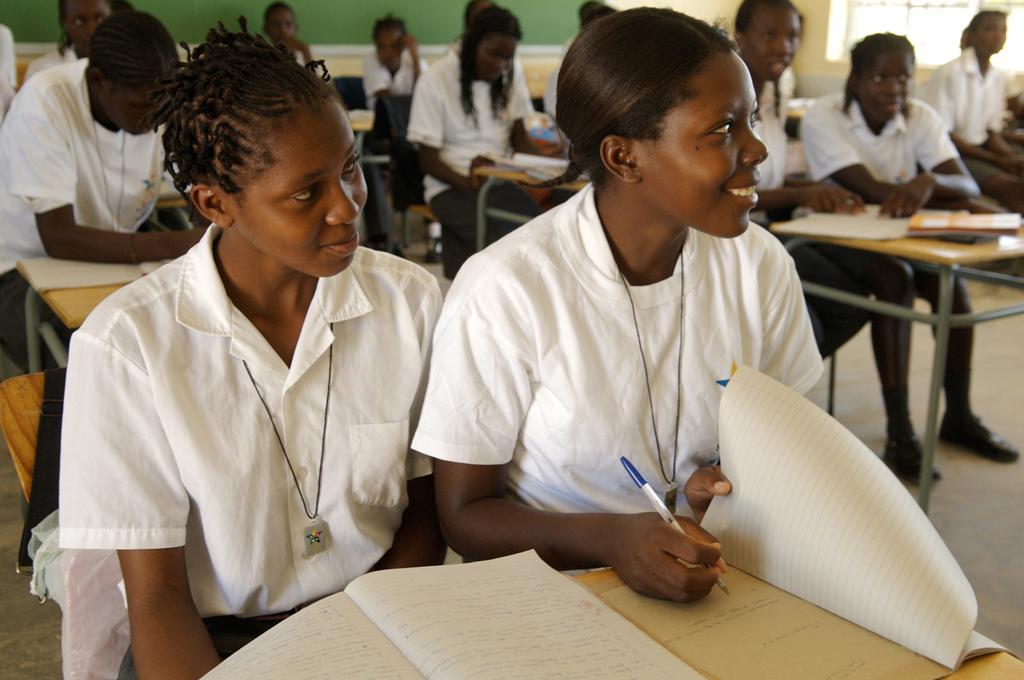Can you describe this image briefly? This picture shows a classroom were people seated on the benches and we see books on the bench 